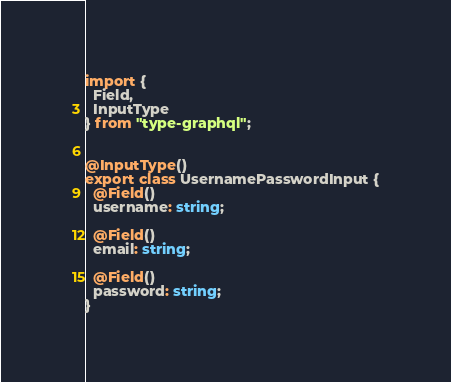Convert code to text. <code><loc_0><loc_0><loc_500><loc_500><_TypeScript_>import {
  Field,
  InputType
} from "type-graphql";


@InputType()
export class UsernamePasswordInput {
  @Field()
  username: string;

  @Field()
  email: string;

  @Field()
  password: string;
}
</code> 